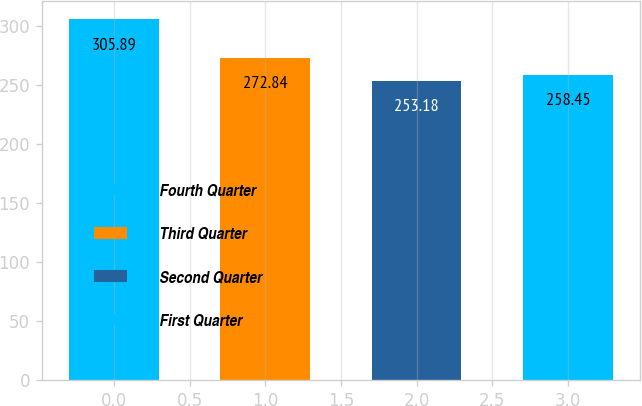Convert chart. <chart><loc_0><loc_0><loc_500><loc_500><bar_chart><fcel>Fourth Quarter<fcel>Third Quarter<fcel>Second Quarter<fcel>First Quarter<nl><fcel>305.89<fcel>272.84<fcel>253.18<fcel>258.45<nl></chart> 